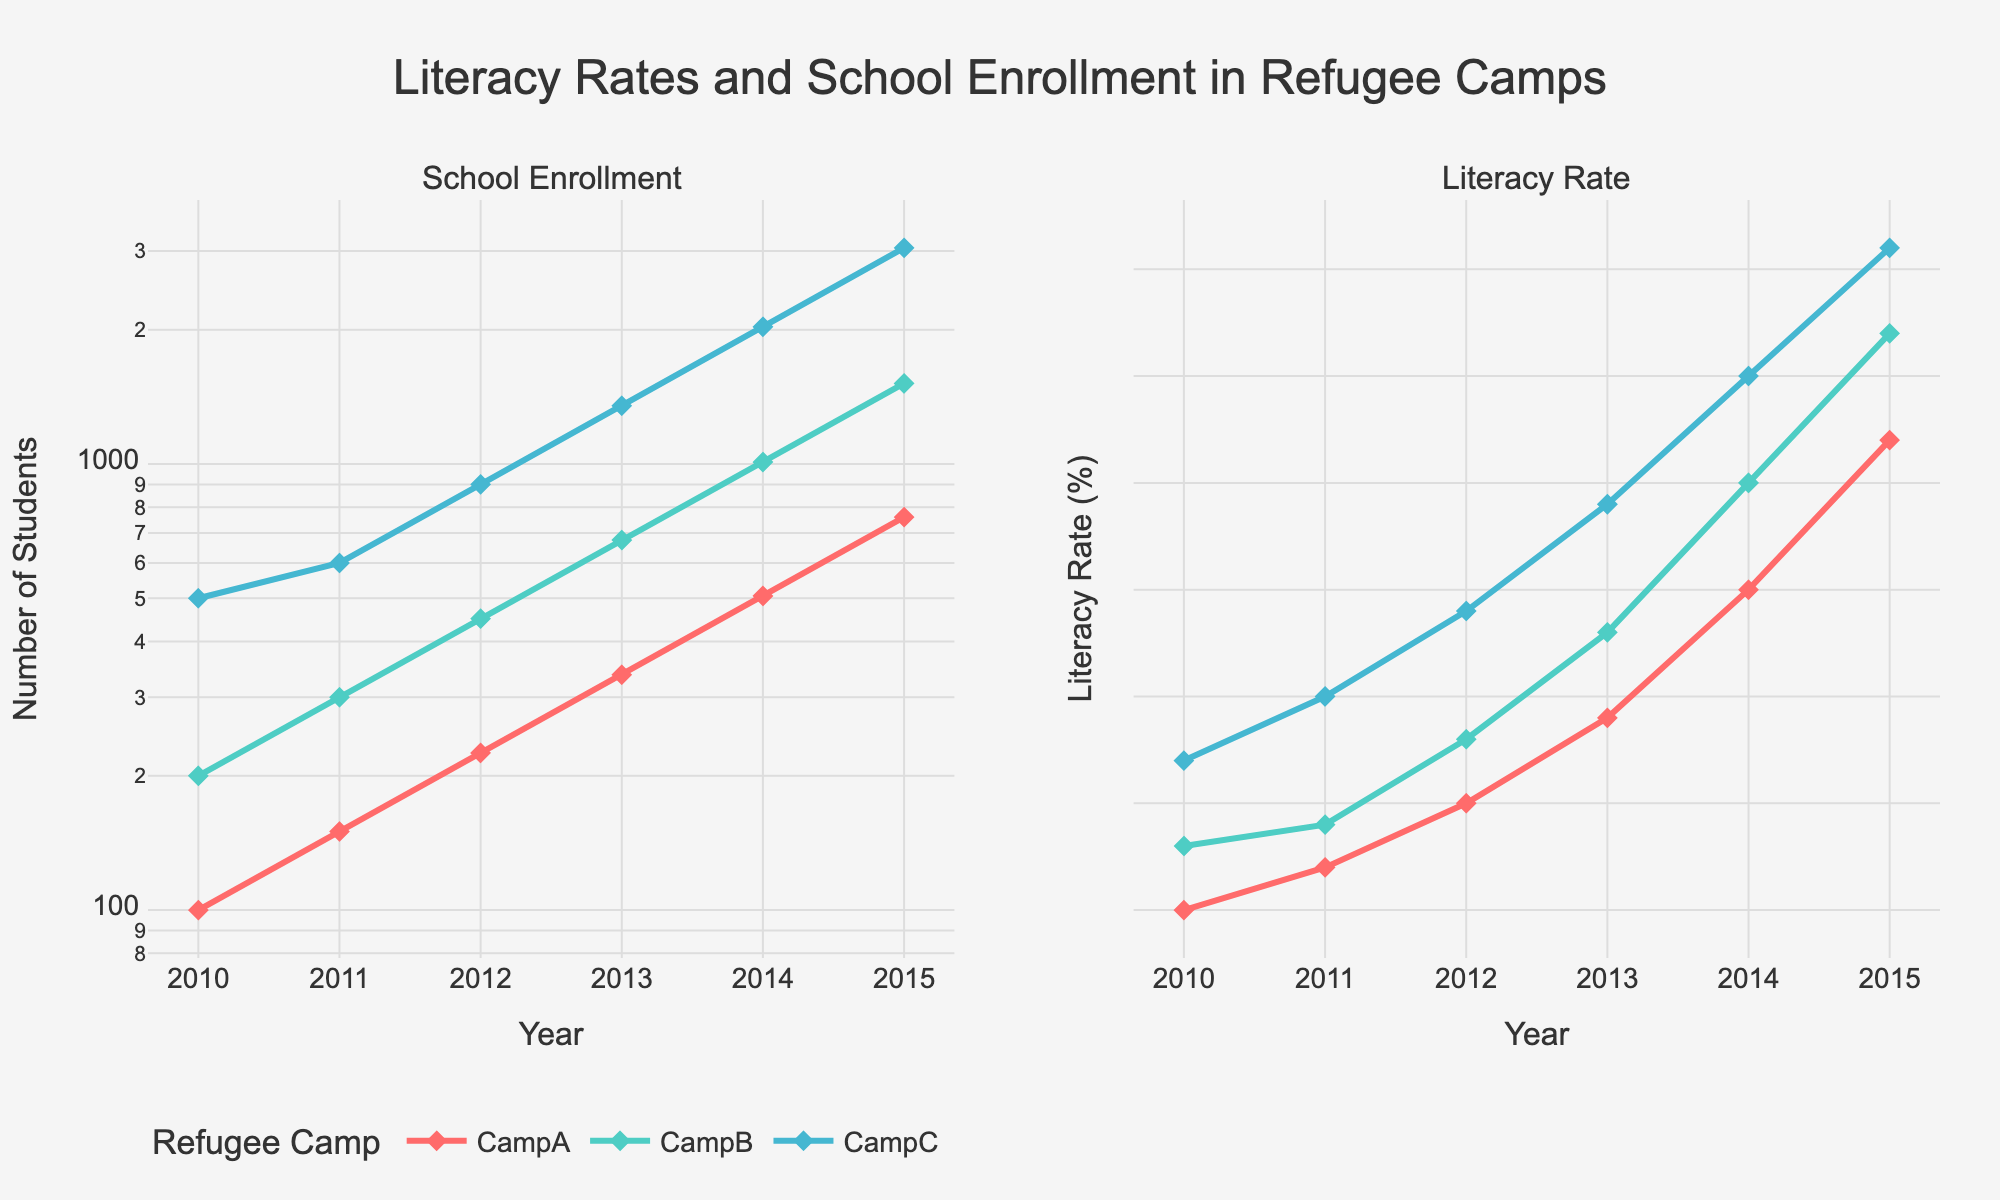What is the title of the figure? The title of the figure is located at the top center and summarizes the main topic of the plot. It reads "Literacy Rates and School Enrollment in Refugee Camps."
Answer: Literacy Rates and School Enrollment in Refugee Camps Which refugee camp had the highest enrollment in 2015? In the School Enrollment plot, the camp with the highest data point in 2015 is the top-most point. This point corresponds to CampC.
Answer: CampC How does the number of students in CampB change from 2012 to 2015? To find the change, subtract the number of students in 2012 from the number of students in 2015. The values are 450 (2012) and 1515 (2015), so the change is 1515 - 450 = 1065.
Answer: 1065 Which camp shows the highest percentage of literate children in 2013? In the Literacy Rate plot, locate the year 2013 and identify the highest point for that year. CampC has the highest percentage of literate children at that point.
Answer: CampC What is the percentage increase in enrollment for CampA from 2010 to 2015? The percentage increase is calculated as: ((Enrollment in 2015 - Enrollment in 2010) / Enrollment in 2010) * 100. For CampA, this is ((760 - 100) / 100) * 100 = 660%.
Answer: 660% Which camp shows the steadiest increase in the percentage of literate children over the years? By observing the smoothness and uniformity of the upward trend lines in the Literacy Rate plot, CampC shows a steady, consistent increase.
Answer: CampC How many students were enrolled in CampA in 2014? Locate the point corresponding to CampA in the School Enrollment plot for the year 2014. The value at this point is 506 students.
Answer: 506 What is the difference in literacy rate between CampB and CampA in 2015? Locate both CampB and CampA's literacy rates in 2015. CampB has 42% and CampA has 37%. The difference is 42% - 37% = 5%.
Answer: 5% Which year marks the start of exponential growth in school enrollment in CampC? Exponential growth is indicated by a rapid upward curve in the School Enrollment plot. For CampC, this appears to start around 2013.
Answer: 2013 Is the literacy rate positively correlated with school enrollment based on the figure? A positive correlation means that as one variable increases, the other also increases. By comparing the trends in both subplots, it is evident that as school enrollment increases, the literacy rate also generally increases.
Answer: Yes 